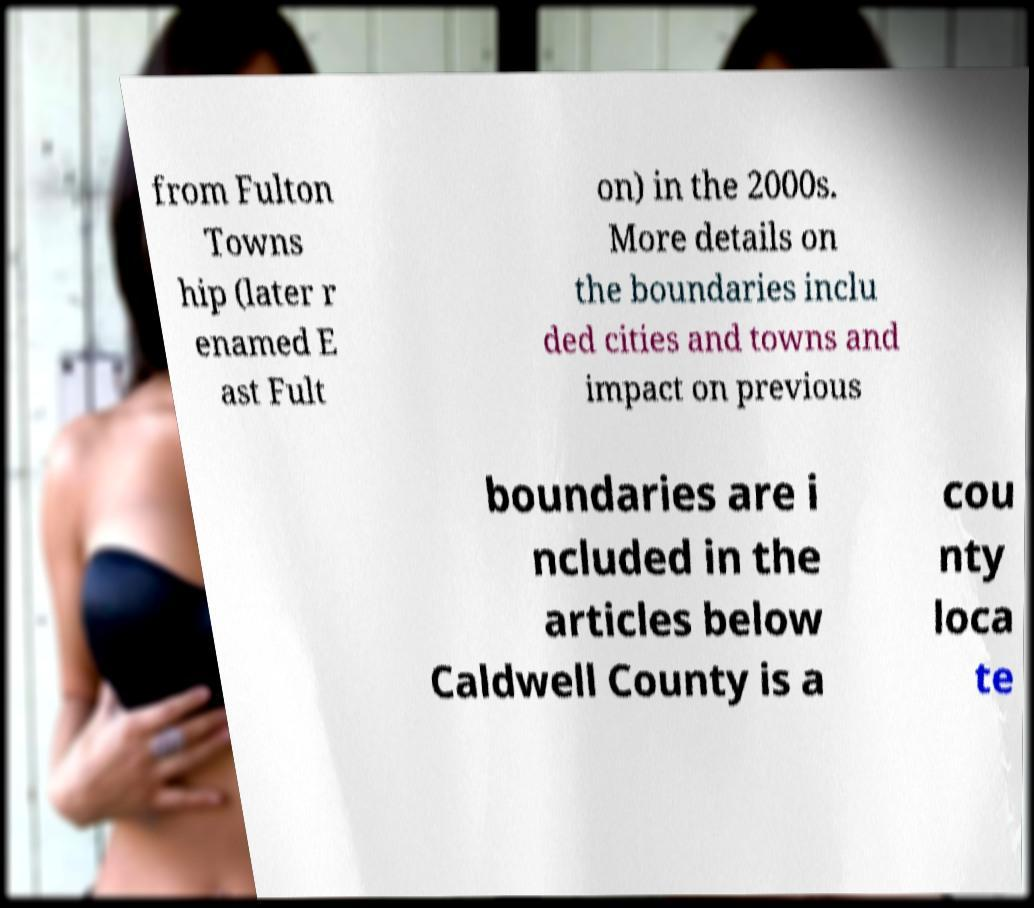Could you extract and type out the text from this image? from Fulton Towns hip (later r enamed E ast Fult on) in the 2000s. More details on the boundaries inclu ded cities and towns and impact on previous boundaries are i ncluded in the articles below Caldwell County is a cou nty loca te 